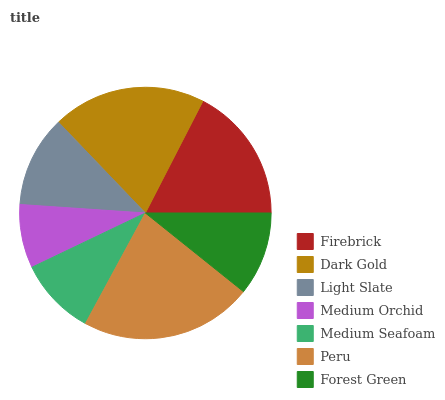Is Medium Orchid the minimum?
Answer yes or no. Yes. Is Peru the maximum?
Answer yes or no. Yes. Is Dark Gold the minimum?
Answer yes or no. No. Is Dark Gold the maximum?
Answer yes or no. No. Is Dark Gold greater than Firebrick?
Answer yes or no. Yes. Is Firebrick less than Dark Gold?
Answer yes or no. Yes. Is Firebrick greater than Dark Gold?
Answer yes or no. No. Is Dark Gold less than Firebrick?
Answer yes or no. No. Is Light Slate the high median?
Answer yes or no. Yes. Is Light Slate the low median?
Answer yes or no. Yes. Is Dark Gold the high median?
Answer yes or no. No. Is Forest Green the low median?
Answer yes or no. No. 